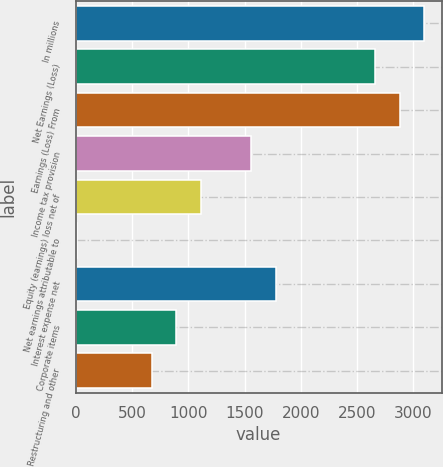Convert chart. <chart><loc_0><loc_0><loc_500><loc_500><bar_chart><fcel>In millions<fcel>Net Earnings (Loss)<fcel>Earnings (Loss) From<fcel>Income tax provision<fcel>Equity (earnings) loss net of<fcel>Net earnings attributable to<fcel>Interest expense net<fcel>Corporate items<fcel>Restructuring and other<nl><fcel>3096.8<fcel>2656.4<fcel>2876.6<fcel>1555.4<fcel>1115<fcel>14<fcel>1775.6<fcel>894.8<fcel>674.6<nl></chart> 